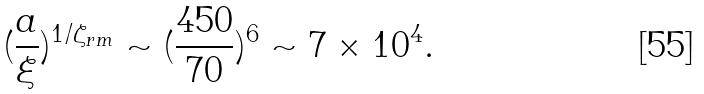<formula> <loc_0><loc_0><loc_500><loc_500>( \frac { a } { \xi } ) ^ { 1 / \zeta _ { r m } } \sim ( \frac { 4 5 0 } { 7 0 } ) ^ { 6 } \sim 7 \times 1 0 ^ { 4 } .</formula> 